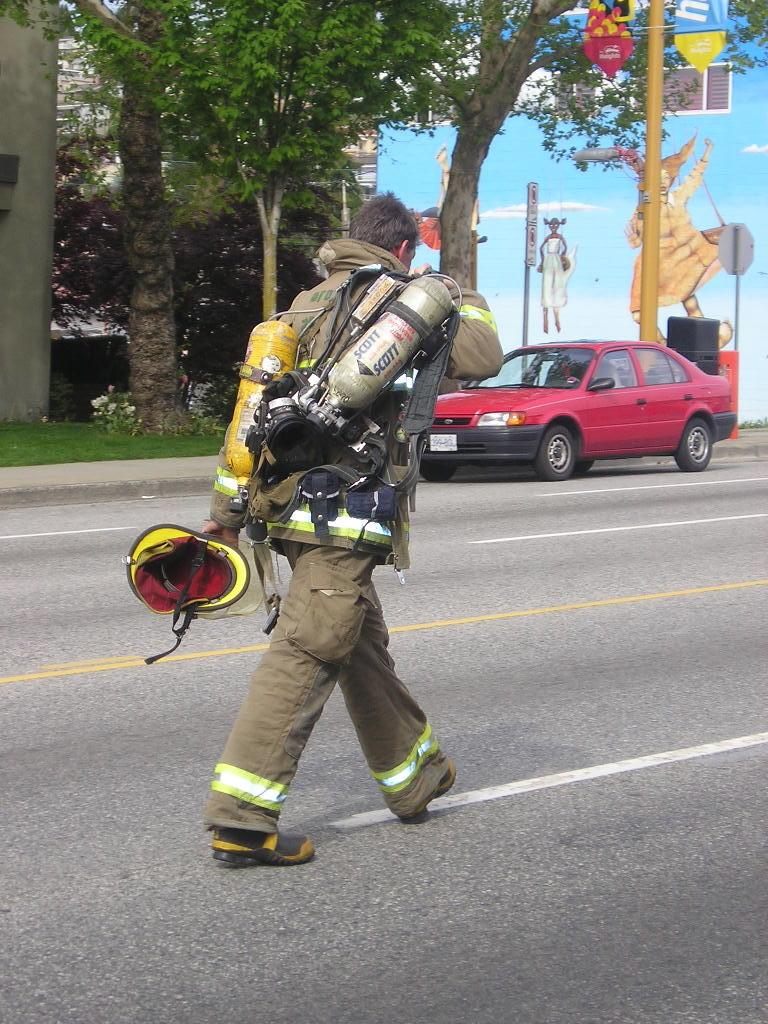What is the person in the image doing? There is a firefighter walking on the road in the image. What is located near the footpath? There is a car on the side of the footpath. What can be seen in the background of the image? Trees are visible in the background. What structure is behind the car and trees? There is a building behind the car and trees. What type of rod can be seen in the hands of the firefighter? There is no rod visible in the hands of the firefighter in the image. How many eggs are present on the road in the image? There are no eggs present on the road in the image. 